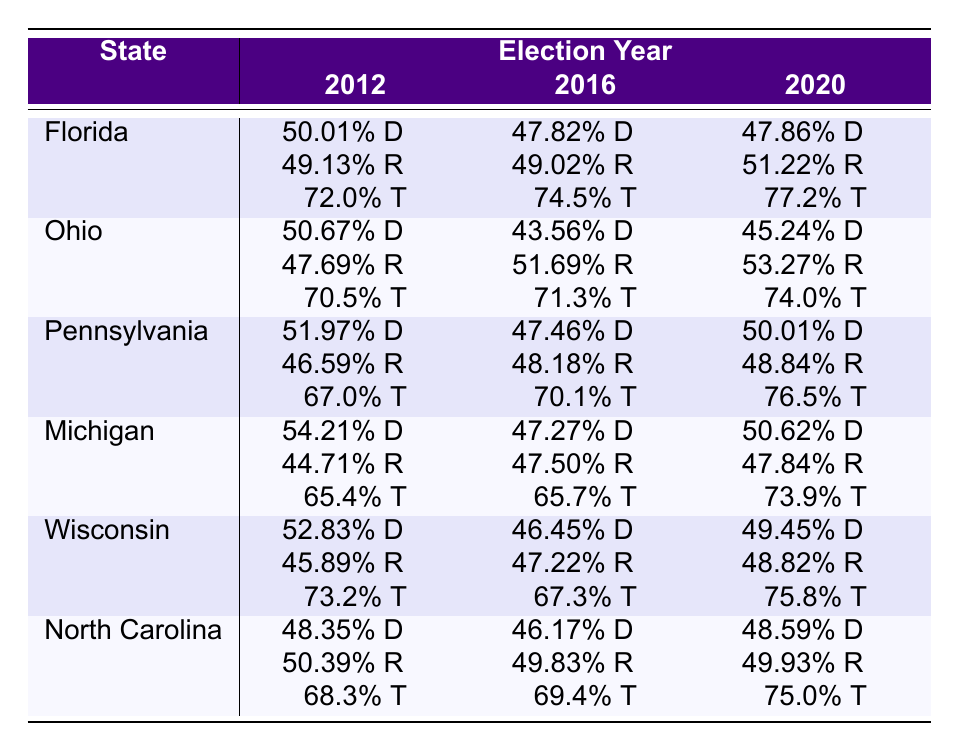What was the Democratic percentage of votes in Florida in 2012? According to the table, Florida's Democratic percentage of votes in 2012 was 50.01%.
Answer: 50.01% Which state had the highest Republican percentage of votes in 2020? In 2020, Florida had the highest Republican percentage of votes at 51.22%.
Answer: Florida What was the overall trend of voter turnout from 2012 to 2020 in Pennsylvania? The voter turnout in Pennsylvania increased from 67.0% in 2012 to 76.5% in 2020, indicating a trend of increased participation.
Answer: Increased In which election year did Ohio show a decline in Democratic votes compared to the previous election? Ohio experienced a decline in Democratic votes from 2012 (50.67%) to 2016 (43.56%), and again from 2016 (43.56%) to 2020 (45.24%).
Answer: 2016 What is the range of voter turnout across all states in 2020? The minimum voter turnout in 2020 was in Florida at 77.2% and the maximum in Wisconsin at 75.8%; thus, the range is calculated as 77.2% - 74.0% = 3.2%.
Answer: 3.2% Was the turnout in Michigan higher in 2020 compared to 2016? Yes, the turnout in Michigan was 73.9% in 2020, which is higher than 65.7% in 2016.
Answer: Yes Calculate the average Democratic percentage of votes across all states in 2012. The Democratic percentages in 2012 were: Florida (50.01%), Ohio (50.67%), Pennsylvania (51.97%), Michigan (54.21%), Wisconsin (52.83%), and North Carolina (48.35%). The total is (50.01 + 50.67 + 51.97 + 54.21 + 52.83 + 48.35) = 308.04%. The average is 308.04% / 6 = 51.34%.
Answer: 51.34% Which state exhibited the largest swing in Democratic votes from 2012 to 2016? Florida showed a significant decrease from 50.01% in 2012 to 47.82% in 2016, a swing of 2.19%.
Answer: Florida Is it true that North Carolina had a Republican lead in all three election years? Yes, North Carolina consistently had higher Republican percentages than Democratic votes in 2012, 2016, and 2020.
Answer: Yes How many states experienced an increase in turnout from 2016 to 2020? States with increased turnout from 2016 to 2020 are Florida (74.5% to 77.2%), Pennsylvania (70.1% to 76.5%), Michigan (65.7% to 73.9%), and Wisconsin (67.3% to 75.8%). This totals 4 states.
Answer: 4 states 